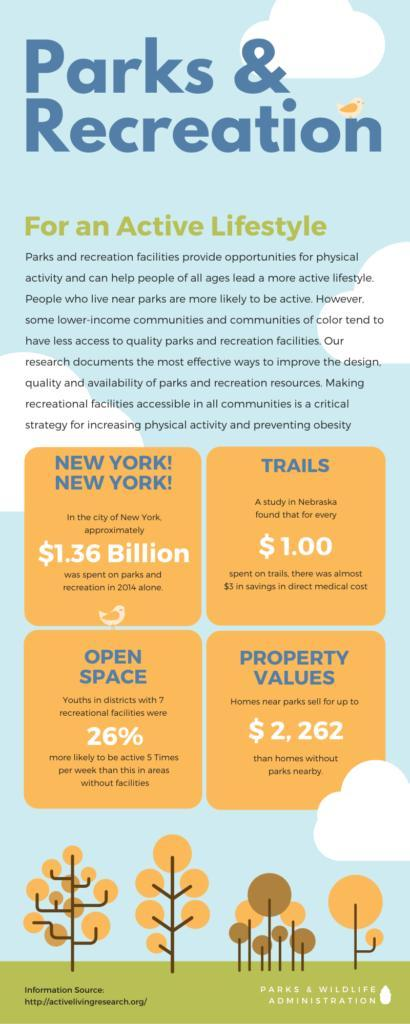what is the value  of a home near a park when compared to the value of a home without a park nearby
Answer the question with a short phrase. $2,262 WHat is the % savings in direct medical cost for every dollar spent on trails 300 What was the amount spent in 2014 in new york for parks and recreation $1.36 billion 